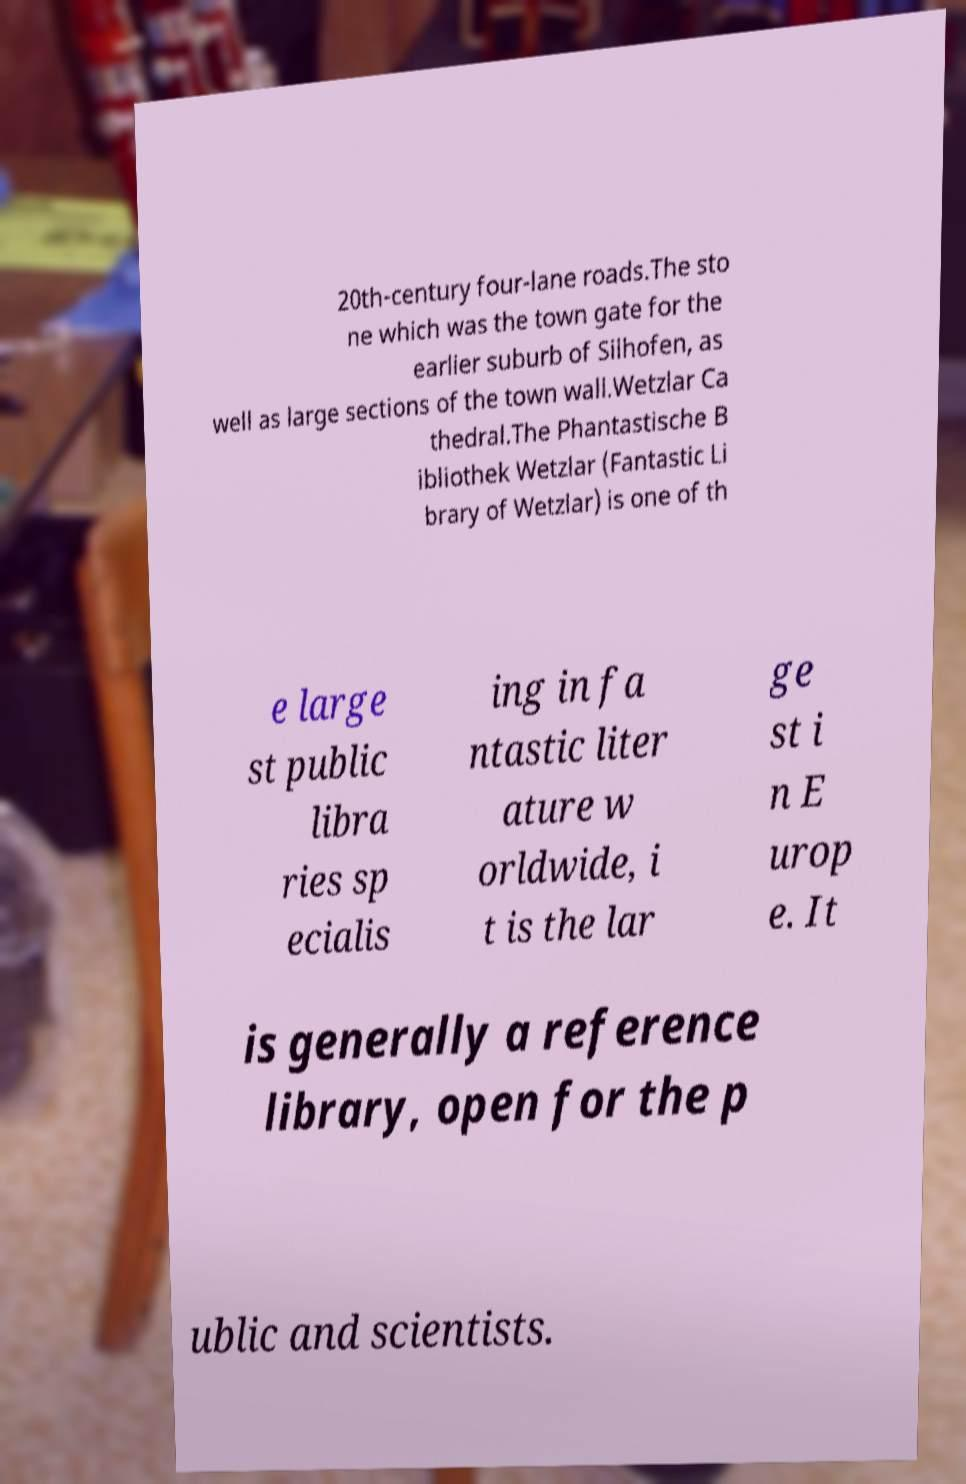For documentation purposes, I need the text within this image transcribed. Could you provide that? 20th-century four-lane roads.The sto ne which was the town gate for the earlier suburb of Silhofen, as well as large sections of the town wall.Wetzlar Ca thedral.The Phantastische B ibliothek Wetzlar (Fantastic Li brary of Wetzlar) is one of th e large st public libra ries sp ecialis ing in fa ntastic liter ature w orldwide, i t is the lar ge st i n E urop e. It is generally a reference library, open for the p ublic and scientists. 